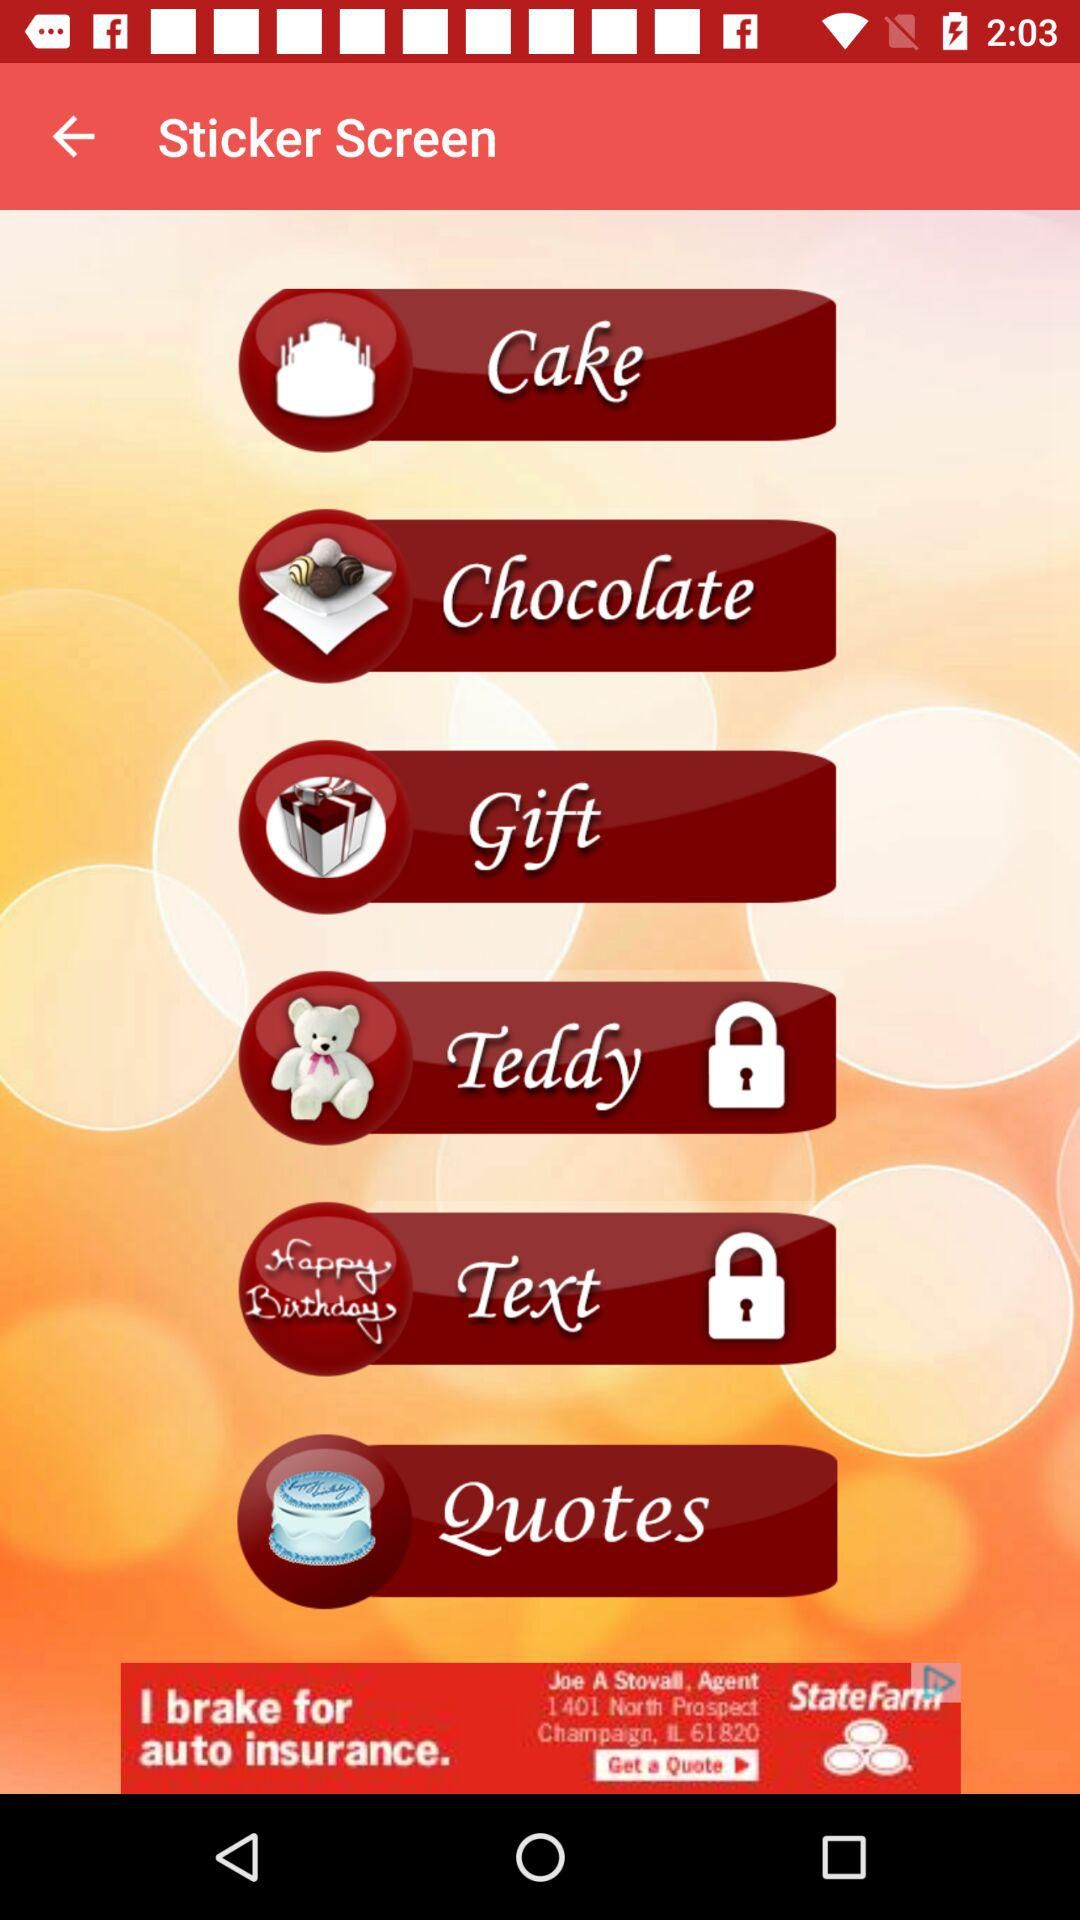How many quotes are there?
When the provided information is insufficient, respond with <no answer>. <no answer> 